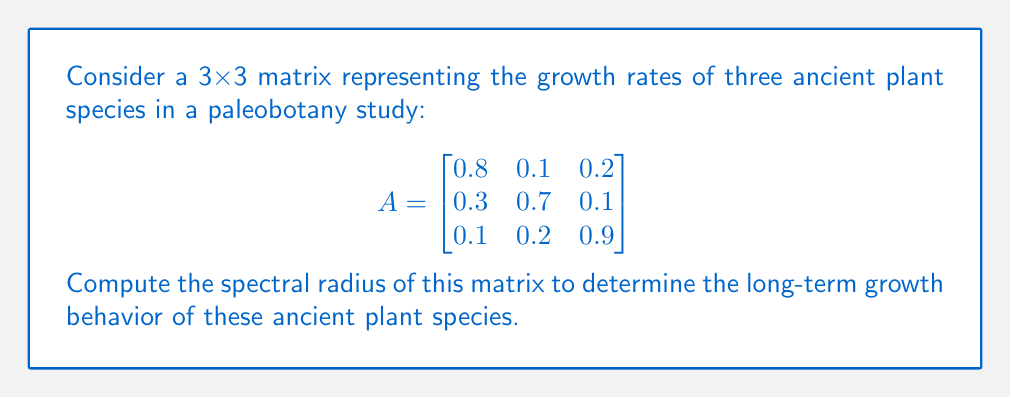Can you solve this math problem? To compute the spectral radius of matrix A, we need to follow these steps:

1) First, calculate the characteristic polynomial of A:
   $det(A - \lambda I) = 0$

   $$\begin{vmatrix}
   0.8-\lambda & 0.1 & 0.2 \\
   0.3 & 0.7-\lambda & 0.1 \\
   0.1 & 0.2 & 0.9-\lambda
   \end{vmatrix} = 0$$

2) Expand the determinant:
   $(0.8-\lambda)(0.7-\lambda)(0.9-\lambda) - 0.1 \cdot 0.1 \cdot 0.1 - 0.2 \cdot 0.3 \cdot 0.2 - (0.8-\lambda) \cdot 0.1 \cdot 0.2 - 0.1 \cdot (0.7-\lambda) \cdot 0.1 - 0.3 \cdot 0.2 \cdot (0.9-\lambda) = 0$

3) Simplify:
   $-\lambda^3 + 2.4\lambda^2 - 1.858\lambda + 0.4583 = 0$

4) Find the roots of this polynomial. These are the eigenvalues of A. Using a numerical method or a computer algebra system, we get:

   $\lambda_1 \approx 1.0383$
   $\lambda_2 \approx 0.7308$
   $\lambda_3 \approx 0.6309$

5) The spectral radius is the maximum absolute value of the eigenvalues:

   $\rho(A) = \max(|\lambda_1|, |\lambda_2|, |\lambda_3|) = |\lambda_1| \approx 1.0383$

This value being slightly greater than 1 indicates that the plant species are slowly growing over time.
Answer: $\rho(A) \approx 1.0383$ 